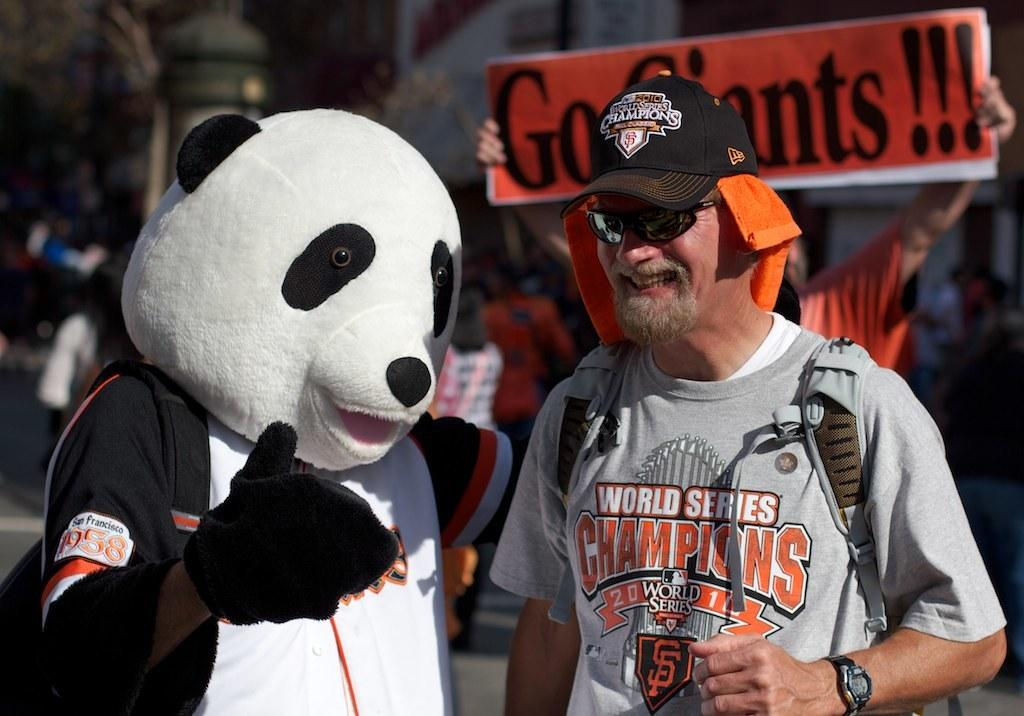<image>
Present a compact description of the photo's key features. A guy wearing a World Series Champions shirt next to a mascot. 